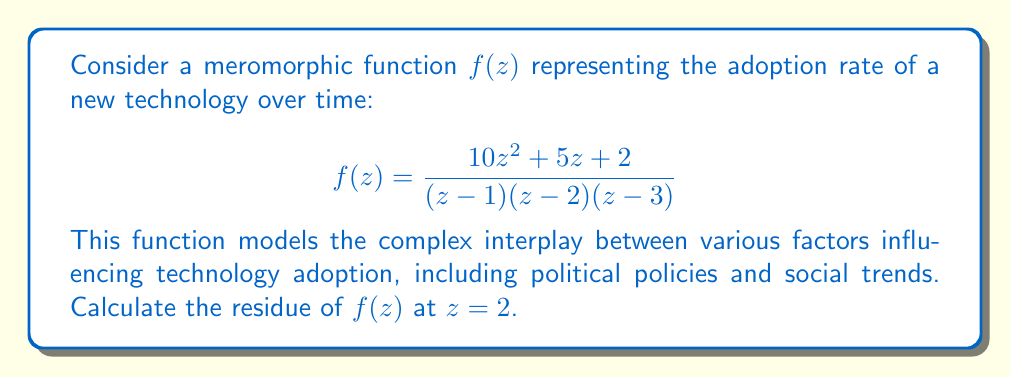What is the answer to this math problem? To calculate the residue of $f(z)$ at $z=2$, we'll use the following approach:

1) The point $z=2$ is a simple pole of $f(z)$, as it appears as a linear factor in the denominator.

2) For a simple pole, we can use the formula:

   $$\text{Res}(f,2) = \lim_{z \to 2} (z-2)f(z)$$

3) Let's simplify our function first:

   $$f(z) = \frac{10z^2 + 5z + 2}{(z-1)(z-2)(z-3)}$$

4) Now, let's apply the residue formula:

   $$\begin{align*}
   \text{Res}(f,2) &= \lim_{z \to 2} (z-2)\frac{10z^2 + 5z + 2}{(z-1)(z-2)(z-3)} \\
   &= \lim_{z \to 2} \frac{10z^2 + 5z + 2}{(z-1)(z-3)}
   \end{align*}$$

5) We can now directly substitute $z=2$:

   $$\begin{align*}
   \text{Res}(f,2) &= \frac{10(2)^2 + 5(2) + 2}{(2-1)(2-3)} \\
   &= \frac{40 + 10 + 2}{(1)(-1)} \\
   &= \frac{52}{-1} \\
   &= -52
   \end{align*}$$

This residue value represents the strength of the singularity in the adoption rate function at $z=2$, which could correspond to a critical point in the technology's lifecycle or a significant policy change.
Answer: The residue of $f(z)$ at $z=2$ is $-52$. 